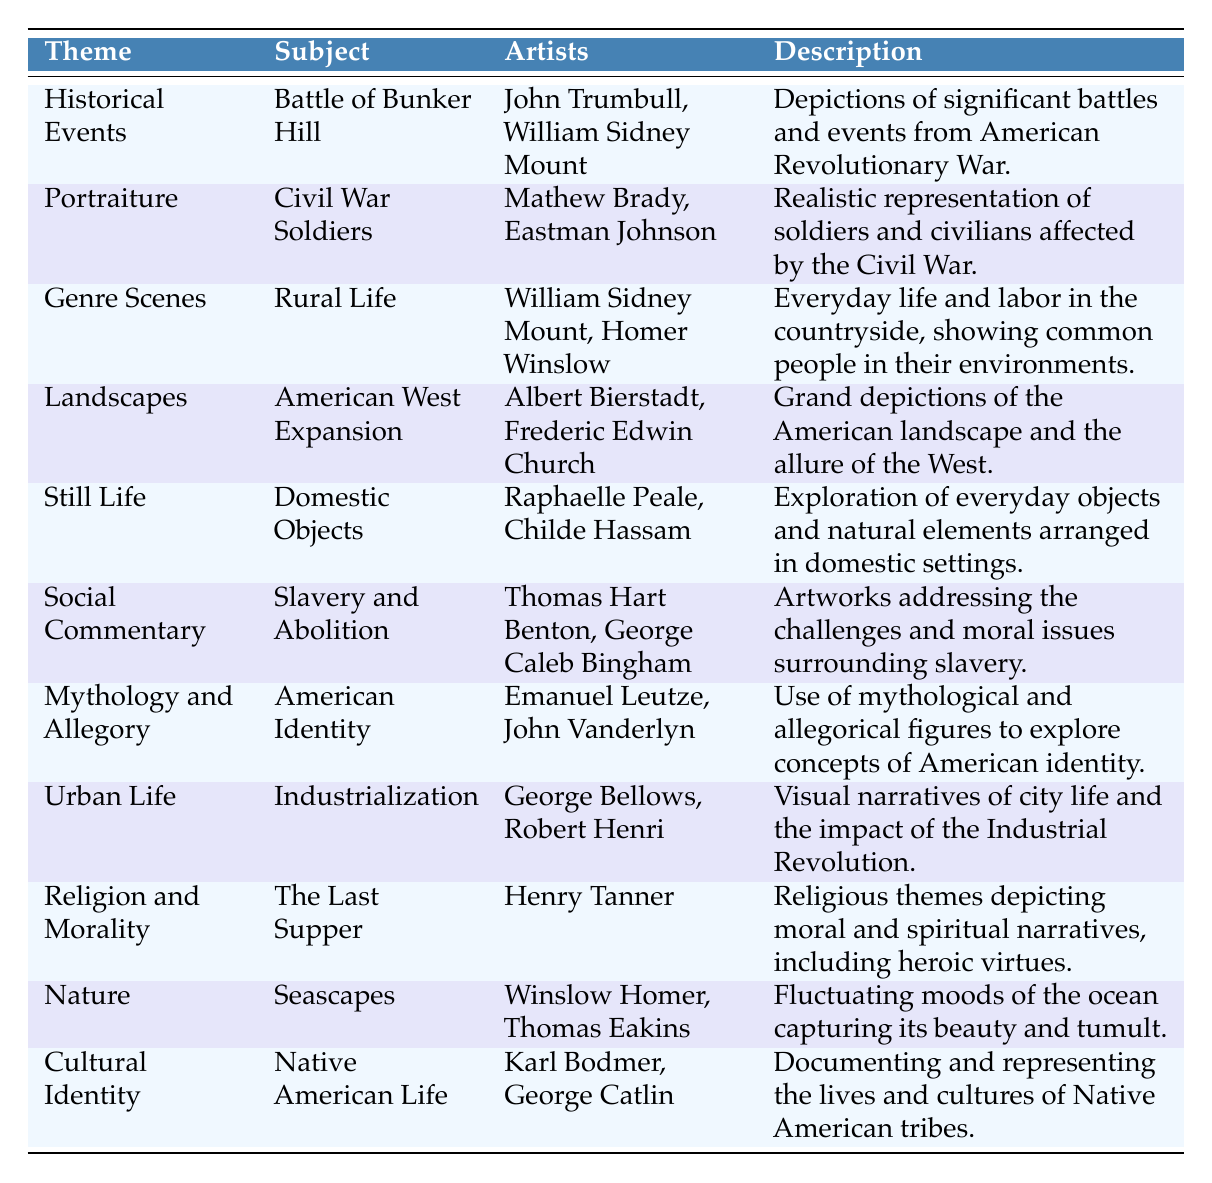What themes are represented in the table? The table provides a list of themes such as Historical Events, Portraiture, Genre Scenes, Landscapes, Still Life, Social Commentary, Mythology and Allegory, Urban Life, Religion and Morality, Nature, and Cultural Identity.
Answer: Historical Events, Portraiture, Genre Scenes, Landscapes, Still Life, Social Commentary, Mythology and Allegory, Urban Life, Religion and Morality, Nature, Cultural Identity Which artists are associated with "Rural Life"? The table lists William Sidney Mount and Homer Winslow as the artists associated with the subject of "Rural Life".
Answer: William Sidney Mount, Homer Winslow How many themes are focused on social issues? There are two themes in the table that focus on social issues: "Social Commentary" and "Cultural Identity". Therefore, the total is 2.
Answer: 2 Is "The Last Supper" a theme or a subject in the table? "The Last Supper" is categorized as a subject under the theme "Religion and Morality".
Answer: Subject Which theme has the most artists listed? "Social Commentary" and "Cultural Identity" both have 2 artists listed. So, the themes with the most artists are those two.
Answer: Social Commentary, Cultural Identity Do the artists listed under "Seascapes" include Winslow Homer? Yes, Winslow Homer is one of the artists listed under the subject of "Seascapes".
Answer: Yes What description is given for "Domestic Objects"? The description for "Domestic Objects" describes an exploration of everyday objects and natural elements arranged in domestic settings.
Answer: Everyday objects and natural elements in domestic settings What are the subjects under the "Landscapes" theme? The subject under the "Landscapes" theme is "American West Expansion".
Answer: American West Expansion Compare the number of subjects in "Nature" to those in "Genre Scenes". "Nature" has 1 subject ("Seascapes") while "Genre Scenes" also has 1 subject ("Rural Life"). Thus, they are equal.
Answer: Equal Can you find an example of art that addresses the issue of slavery? The subject "Slavery and Abolition" under the theme "Social Commentary" addresses the issue of slavery.
Answer: Yes Which artists are linked to the theme of "Industrialization"? The theme of "Urban Life" links to the artists George Bellows and Robert Henri.
Answer: George Bellows, Robert Henri 